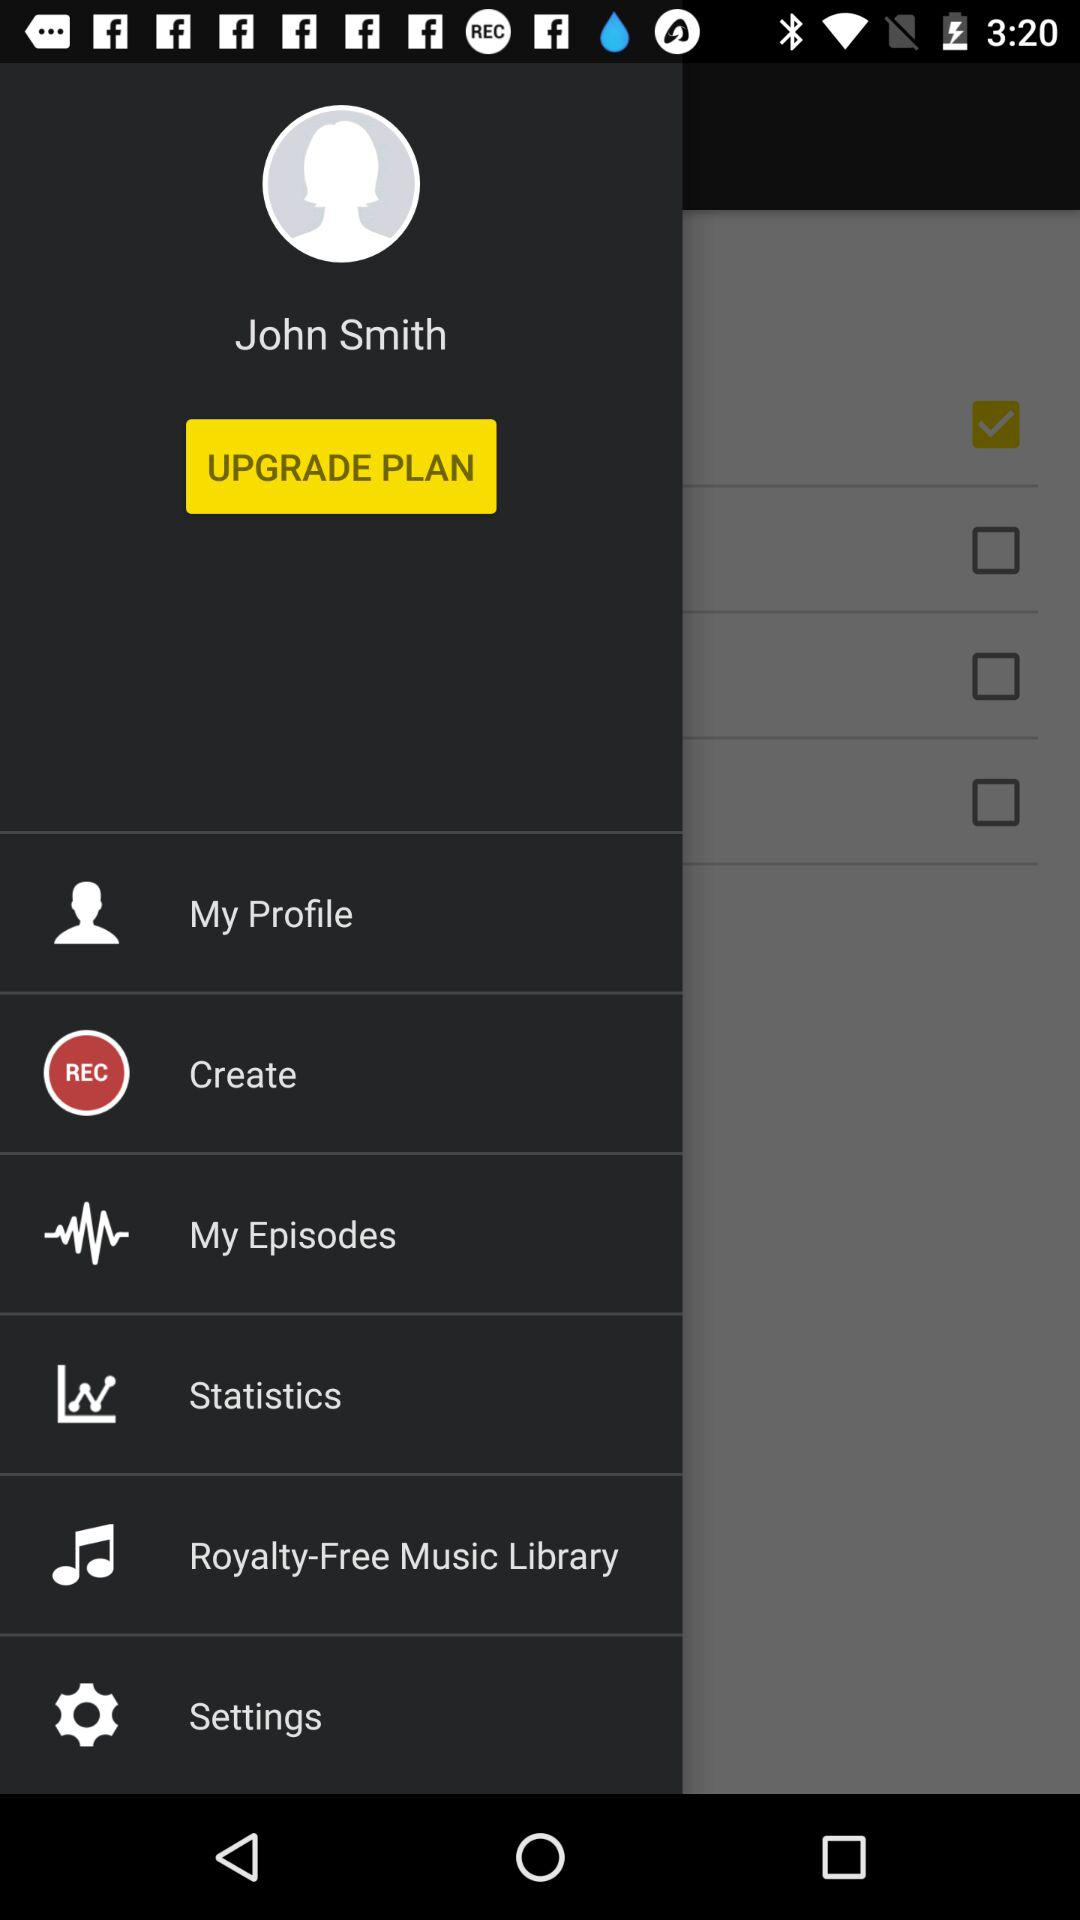What is the name of the user? The name of the user is John Smith. 